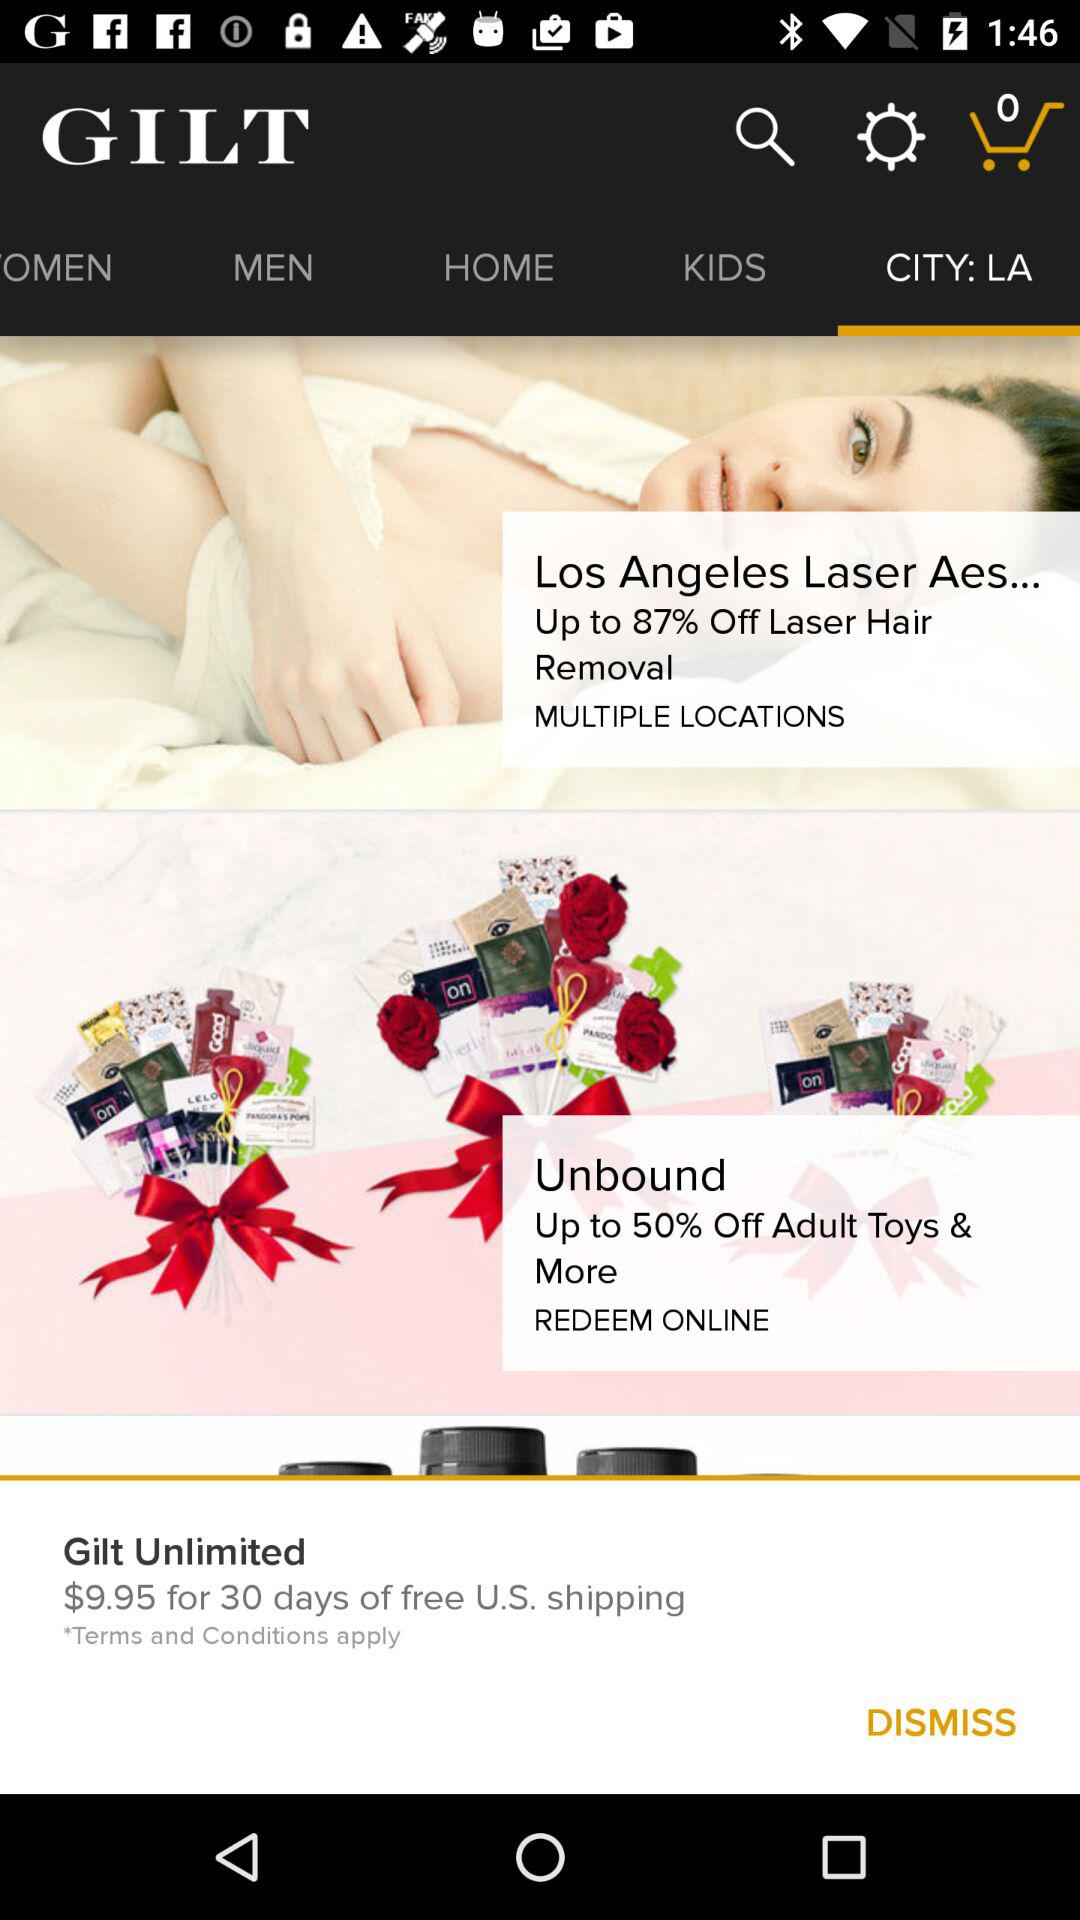How many items are in the cart? There are zero items. 